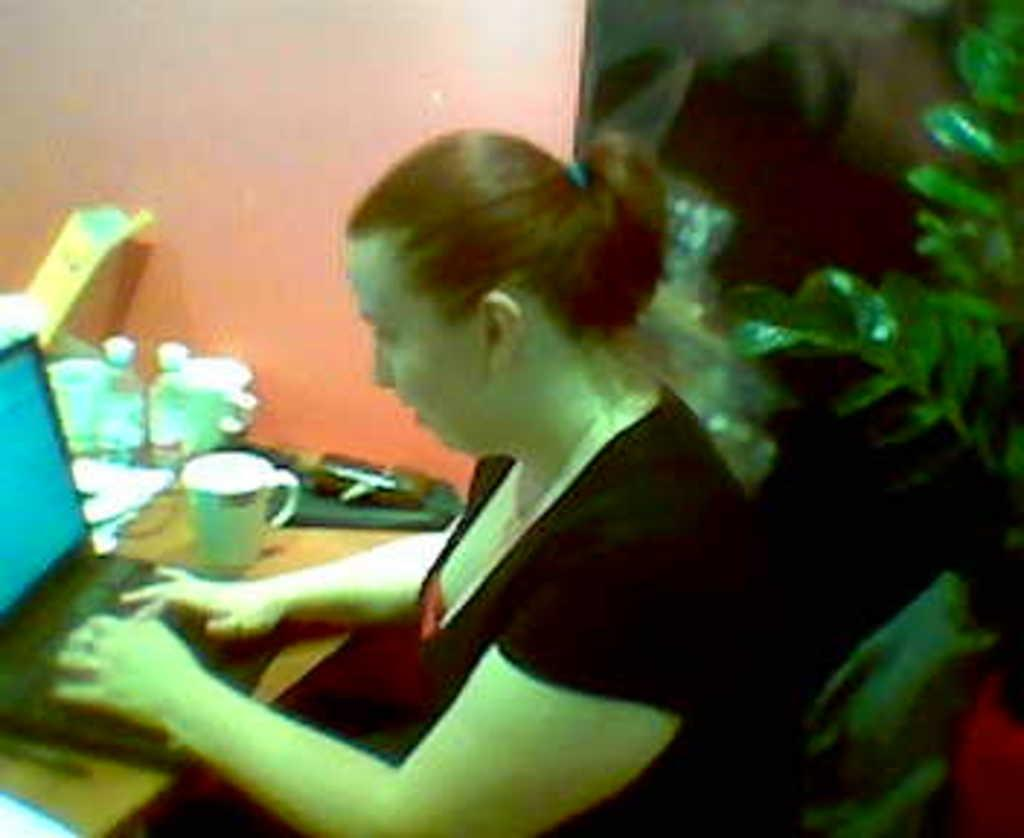What is the person in the image doing? The person is sitting on a chair and operating a laptop in the image. What can be seen on the table in the image? There are bottles, a cup, and other objects on the table in the image. What is visible in the background of the image? There is a wall in the background of the image. Can you tell me how many girls are playing a game on the table in the image? There is no mention of a girl or a game in the image. 